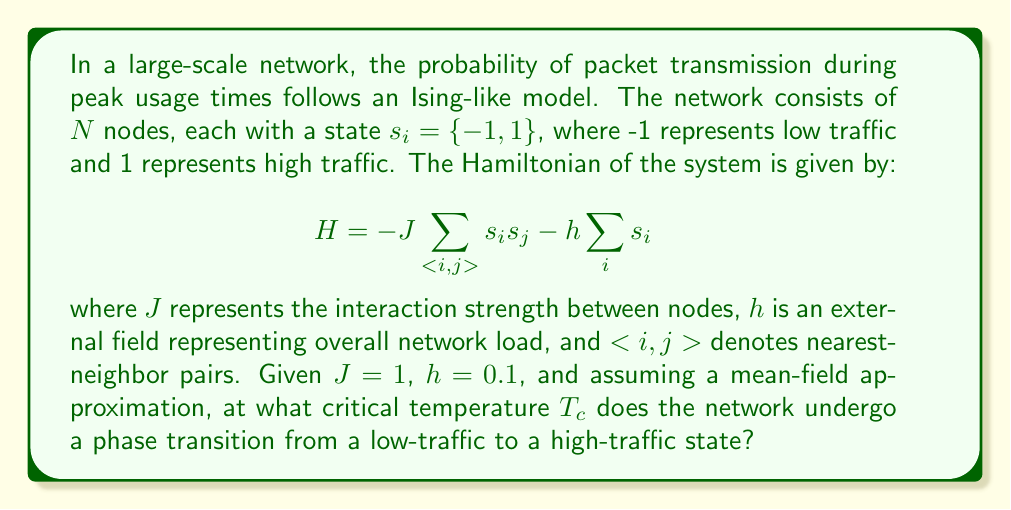Can you answer this question? To solve this problem, we'll use the mean-field approximation for the Ising model:

1. In the mean-field theory, we assume each spin interacts with the average magnetization $m = \langle s_i \rangle$ of the system.

2. The effective field experienced by each spin is:

   $$h_{eff} = zJm + h$$

   where $z$ is the number of nearest neighbors (coordination number).

3. The self-consistent equation for magnetization is:

   $$m = \tanh(\beta h_{eff}) = \tanh(\beta(zJm + h))$$

   where $\beta = \frac{1}{k_BT}$, $k_B$ is the Boltzmann constant, and $T$ is temperature.

4. At the critical temperature $T_c$, the magnetization transitions from zero to non-zero. This occurs when the slope of $\tanh(\beta h_{eff})$ at $m=0$ equals 1:

   $$\left.\frac{d}{dm}\tanh(\beta(zJm + h))\right|_{m=0} = 1$$

5. Evaluating this derivative:

   $$\beta zJ [1 - \tanh^2(\beta h)] = 1$$

6. For small $h$, we can approximate $\tanh(\beta h) \approx \beta h$, giving:

   $$\beta zJ (1 - (\beta h)^2) \approx 1$$

7. Solving for $T_c = \frac{1}{k_B\beta_c}$:

   $$T_c \approx \frac{zJ}{k_B}\left(1 + \frac{h^2}{(zJ)^2}\right)$$

8. Given $J = 1$, $h = 0.1$, and assuming a typical value of $z = 4$ for a 2D lattice:

   $$T_c \approx \frac{4}{k_B}\left(1 + \frac{0.1^2}{16}\right) \approx \frac{4.000625}{k_B}$$
Answer: $T_c \approx \frac{4.000625}{k_B}$ 